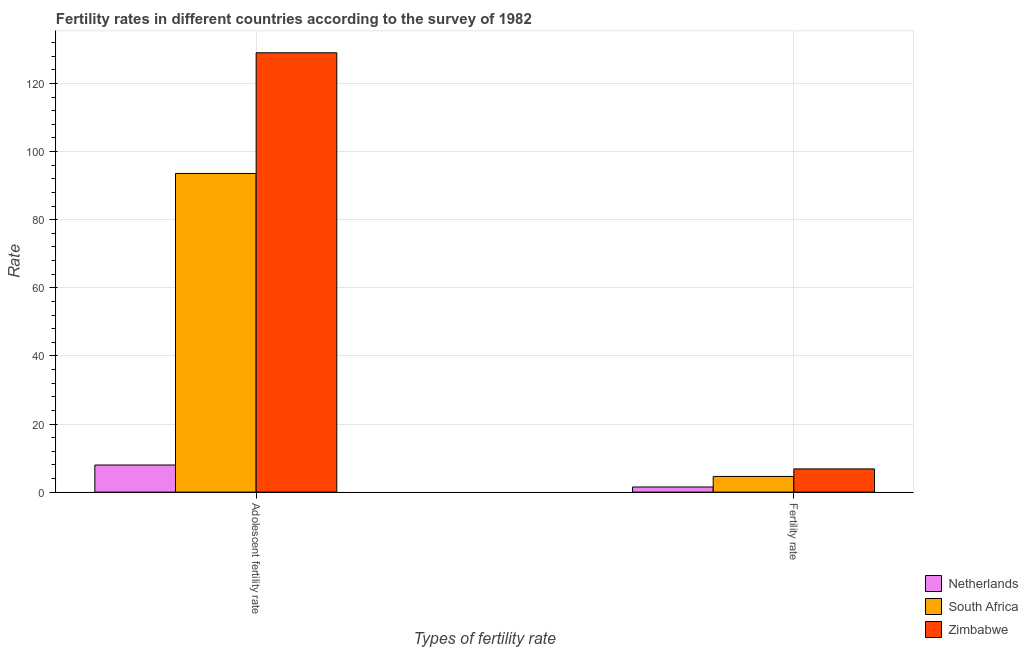Are the number of bars per tick equal to the number of legend labels?
Your answer should be very brief. Yes. What is the label of the 1st group of bars from the left?
Your response must be concise. Adolescent fertility rate. What is the adolescent fertility rate in South Africa?
Ensure brevity in your answer.  93.58. Across all countries, what is the maximum adolescent fertility rate?
Offer a terse response. 129.02. Across all countries, what is the minimum fertility rate?
Your answer should be compact. 1.5. In which country was the adolescent fertility rate maximum?
Provide a short and direct response. Zimbabwe. What is the total fertility rate in the graph?
Provide a succinct answer. 12.91. What is the difference between the fertility rate in South Africa and that in Netherlands?
Offer a terse response. 3.1. What is the difference between the fertility rate in Netherlands and the adolescent fertility rate in South Africa?
Ensure brevity in your answer.  -92.08. What is the average fertility rate per country?
Your answer should be very brief. 4.3. What is the difference between the fertility rate and adolescent fertility rate in South Africa?
Provide a short and direct response. -88.98. What is the ratio of the fertility rate in South Africa to that in Zimbabwe?
Give a very brief answer. 0.68. Is the adolescent fertility rate in Zimbabwe less than that in Netherlands?
Make the answer very short. No. What does the 1st bar from the left in Adolescent fertility rate represents?
Your answer should be compact. Netherlands. What does the 2nd bar from the right in Fertility rate represents?
Ensure brevity in your answer.  South Africa. Are all the bars in the graph horizontal?
Give a very brief answer. No. Does the graph contain any zero values?
Make the answer very short. No. Where does the legend appear in the graph?
Give a very brief answer. Bottom right. How many legend labels are there?
Your response must be concise. 3. What is the title of the graph?
Your response must be concise. Fertility rates in different countries according to the survey of 1982. What is the label or title of the X-axis?
Give a very brief answer. Types of fertility rate. What is the label or title of the Y-axis?
Your answer should be very brief. Rate. What is the Rate in Netherlands in Adolescent fertility rate?
Provide a short and direct response. 7.96. What is the Rate in South Africa in Adolescent fertility rate?
Your answer should be compact. 93.58. What is the Rate of Zimbabwe in Adolescent fertility rate?
Give a very brief answer. 129.02. What is the Rate of South Africa in Fertility rate?
Your answer should be compact. 4.6. What is the Rate in Zimbabwe in Fertility rate?
Keep it short and to the point. 6.81. Across all Types of fertility rate, what is the maximum Rate in Netherlands?
Offer a terse response. 7.96. Across all Types of fertility rate, what is the maximum Rate in South Africa?
Make the answer very short. 93.58. Across all Types of fertility rate, what is the maximum Rate in Zimbabwe?
Make the answer very short. 129.02. Across all Types of fertility rate, what is the minimum Rate of Netherlands?
Your answer should be compact. 1.5. Across all Types of fertility rate, what is the minimum Rate in South Africa?
Your answer should be compact. 4.6. Across all Types of fertility rate, what is the minimum Rate in Zimbabwe?
Your response must be concise. 6.81. What is the total Rate in Netherlands in the graph?
Provide a succinct answer. 9.46. What is the total Rate in South Africa in the graph?
Ensure brevity in your answer.  98.18. What is the total Rate of Zimbabwe in the graph?
Your response must be concise. 135.83. What is the difference between the Rate of Netherlands in Adolescent fertility rate and that in Fertility rate?
Offer a terse response. 6.46. What is the difference between the Rate in South Africa in Adolescent fertility rate and that in Fertility rate?
Offer a very short reply. 88.98. What is the difference between the Rate in Zimbabwe in Adolescent fertility rate and that in Fertility rate?
Keep it short and to the point. 122.21. What is the difference between the Rate in Netherlands in Adolescent fertility rate and the Rate in South Africa in Fertility rate?
Provide a short and direct response. 3.36. What is the difference between the Rate of Netherlands in Adolescent fertility rate and the Rate of Zimbabwe in Fertility rate?
Provide a succinct answer. 1.15. What is the difference between the Rate in South Africa in Adolescent fertility rate and the Rate in Zimbabwe in Fertility rate?
Offer a very short reply. 86.77. What is the average Rate of Netherlands per Types of fertility rate?
Offer a terse response. 4.73. What is the average Rate of South Africa per Types of fertility rate?
Your answer should be compact. 49.09. What is the average Rate in Zimbabwe per Types of fertility rate?
Your answer should be very brief. 67.91. What is the difference between the Rate of Netherlands and Rate of South Africa in Adolescent fertility rate?
Offer a very short reply. -85.62. What is the difference between the Rate of Netherlands and Rate of Zimbabwe in Adolescent fertility rate?
Your answer should be compact. -121.06. What is the difference between the Rate in South Africa and Rate in Zimbabwe in Adolescent fertility rate?
Offer a terse response. -35.44. What is the difference between the Rate of Netherlands and Rate of South Africa in Fertility rate?
Provide a short and direct response. -3.1. What is the difference between the Rate of Netherlands and Rate of Zimbabwe in Fertility rate?
Provide a short and direct response. -5.31. What is the difference between the Rate of South Africa and Rate of Zimbabwe in Fertility rate?
Give a very brief answer. -2.21. What is the ratio of the Rate of Netherlands in Adolescent fertility rate to that in Fertility rate?
Give a very brief answer. 5.31. What is the ratio of the Rate in South Africa in Adolescent fertility rate to that in Fertility rate?
Provide a short and direct response. 20.33. What is the ratio of the Rate of Zimbabwe in Adolescent fertility rate to that in Fertility rate?
Your response must be concise. 18.94. What is the difference between the highest and the second highest Rate of Netherlands?
Give a very brief answer. 6.46. What is the difference between the highest and the second highest Rate in South Africa?
Offer a very short reply. 88.98. What is the difference between the highest and the second highest Rate of Zimbabwe?
Make the answer very short. 122.21. What is the difference between the highest and the lowest Rate of Netherlands?
Your answer should be compact. 6.46. What is the difference between the highest and the lowest Rate of South Africa?
Make the answer very short. 88.98. What is the difference between the highest and the lowest Rate of Zimbabwe?
Offer a very short reply. 122.21. 